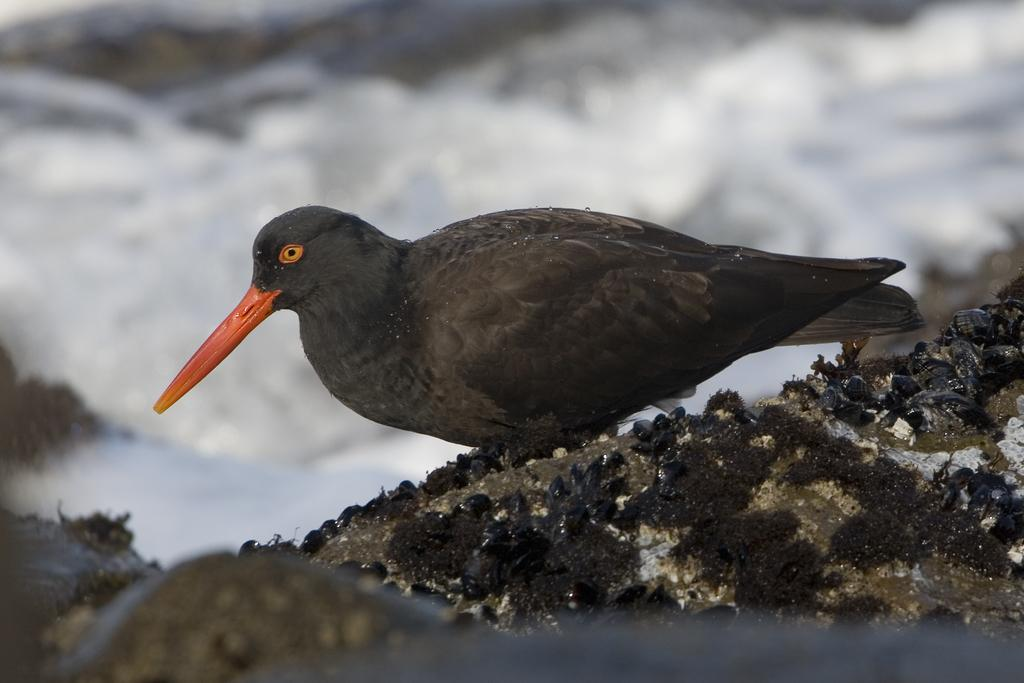What is the main subject of the picture? The main subject of the picture is a bird. Can you describe the bird's appearance? The bird is black in color. What can be observed about the background of the image? The background of the image is blurred. What type of destruction is the bird causing in the image? There is no destruction present in the image; it simply features a black bird in the middle of the picture. How many pears can be seen in the image? There are no pears present in the image. 